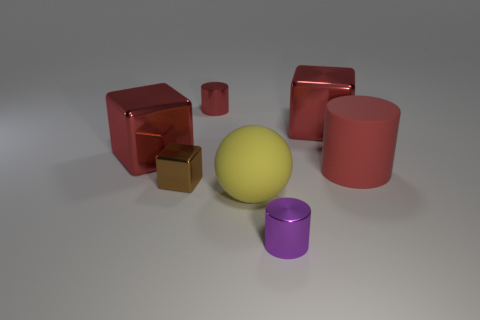Add 1 small gray blocks. How many objects exist? 8 Subtract all cylinders. How many objects are left? 4 Add 6 small metallic cylinders. How many small metallic cylinders are left? 8 Add 7 blocks. How many blocks exist? 10 Subtract 0 purple balls. How many objects are left? 7 Subtract all tiny gray matte cubes. Subtract all red matte things. How many objects are left? 6 